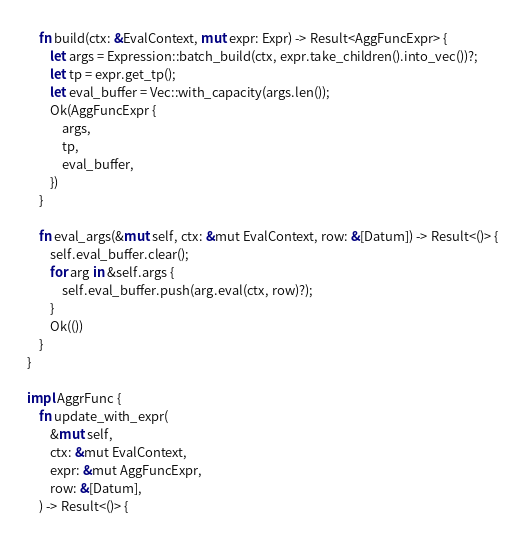Convert code to text. <code><loc_0><loc_0><loc_500><loc_500><_Rust_>
    fn build(ctx: &EvalContext, mut expr: Expr) -> Result<AggFuncExpr> {
        let args = Expression::batch_build(ctx, expr.take_children().into_vec())?;
        let tp = expr.get_tp();
        let eval_buffer = Vec::with_capacity(args.len());
        Ok(AggFuncExpr {
            args,
            tp,
            eval_buffer,
        })
    }

    fn eval_args(&mut self, ctx: &mut EvalContext, row: &[Datum]) -> Result<()> {
        self.eval_buffer.clear();
        for arg in &self.args {
            self.eval_buffer.push(arg.eval(ctx, row)?);
        }
        Ok(())
    }
}

impl AggrFunc {
    fn update_with_expr(
        &mut self,
        ctx: &mut EvalContext,
        expr: &mut AggFuncExpr,
        row: &[Datum],
    ) -> Result<()> {</code> 